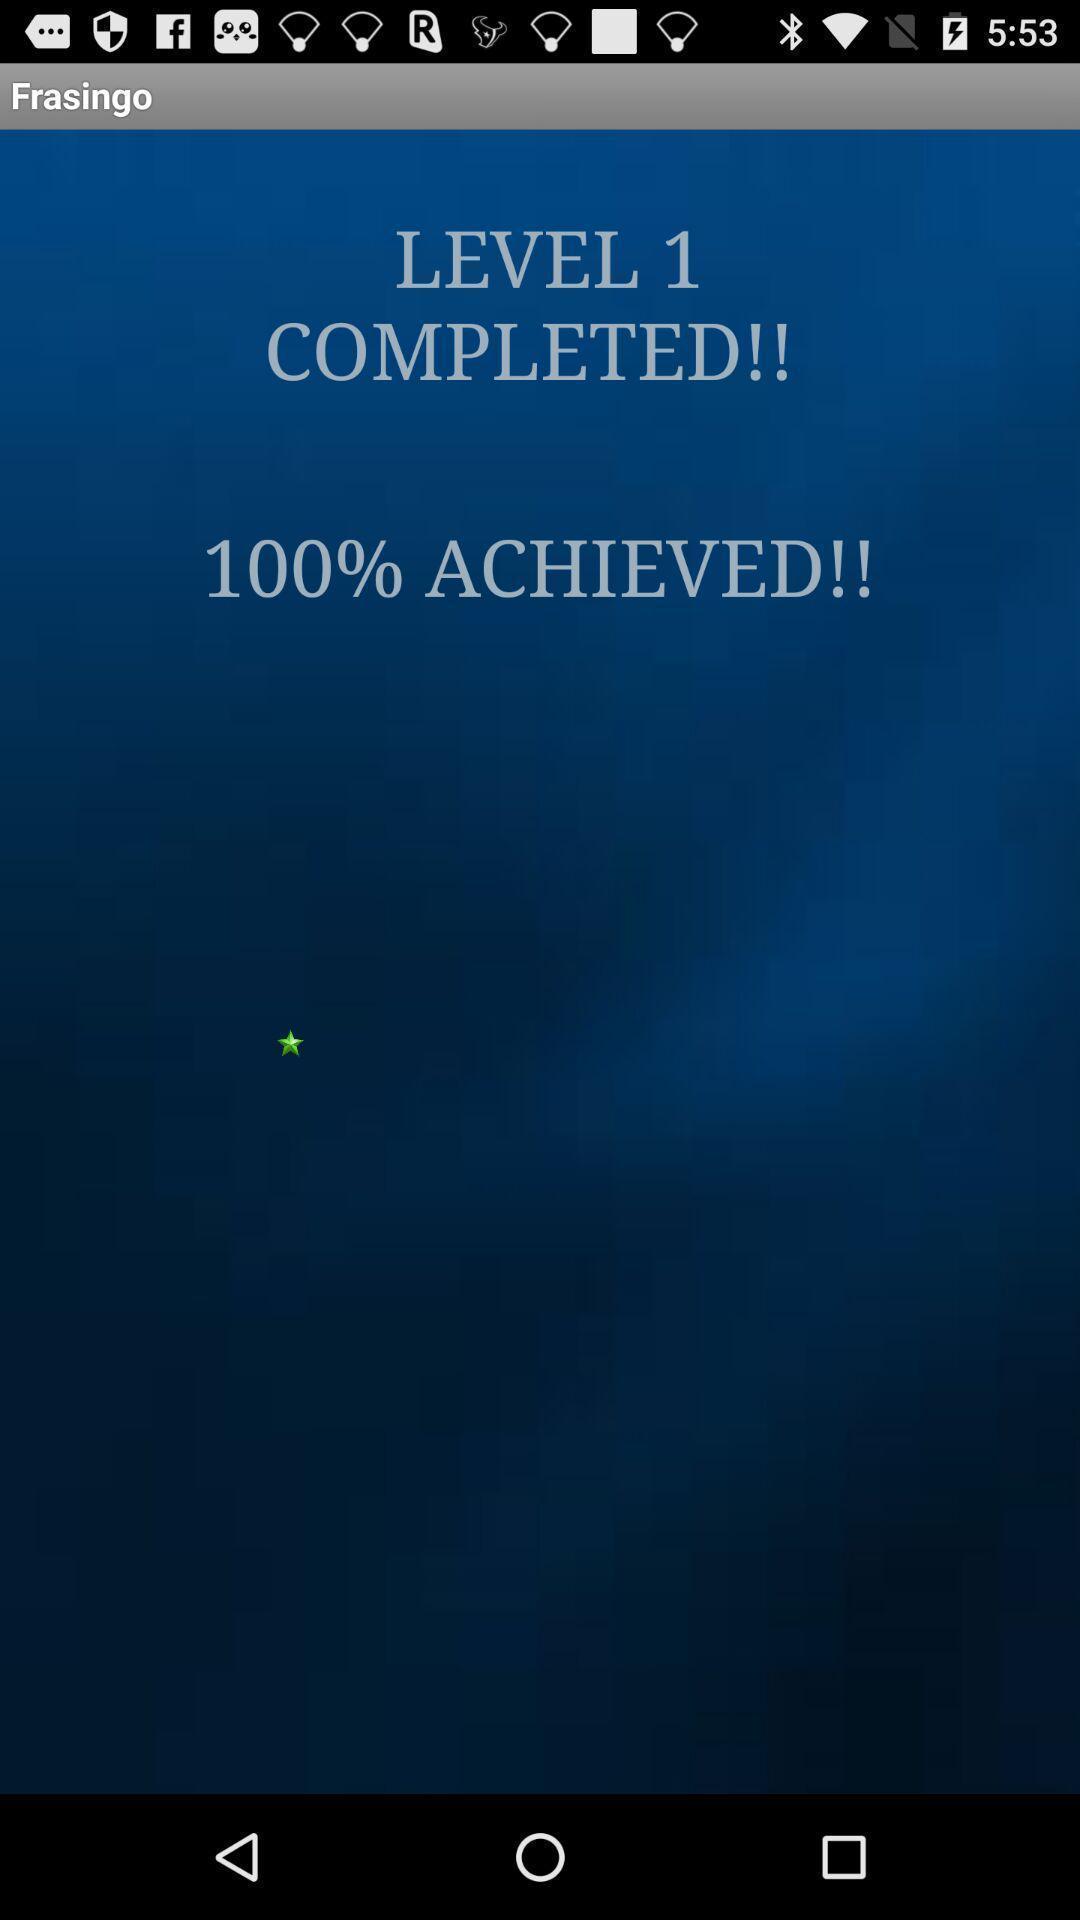Provide a description of this screenshot. Status of a task is displaying. 